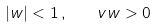<formula> <loc_0><loc_0><loc_500><loc_500>| w | < 1 \, , \quad v w > 0 \,</formula> 